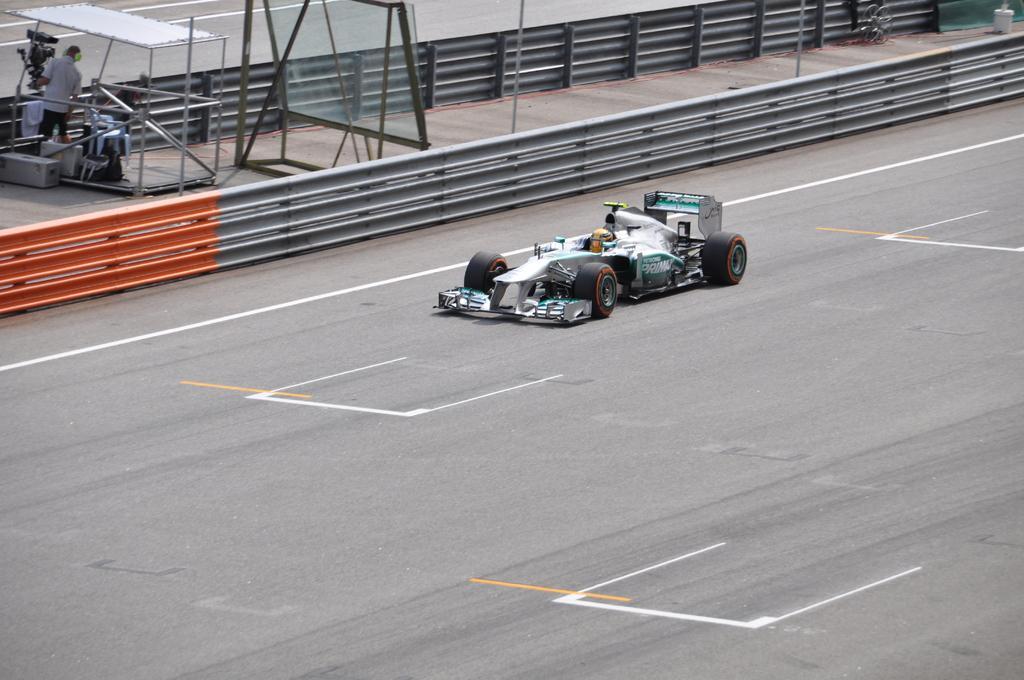Could you give a brief overview of what you see in this image? This image is clicked outside. There is a person in the top left corner. There is a small vehicle in the middle. In that there is a person sitting. 